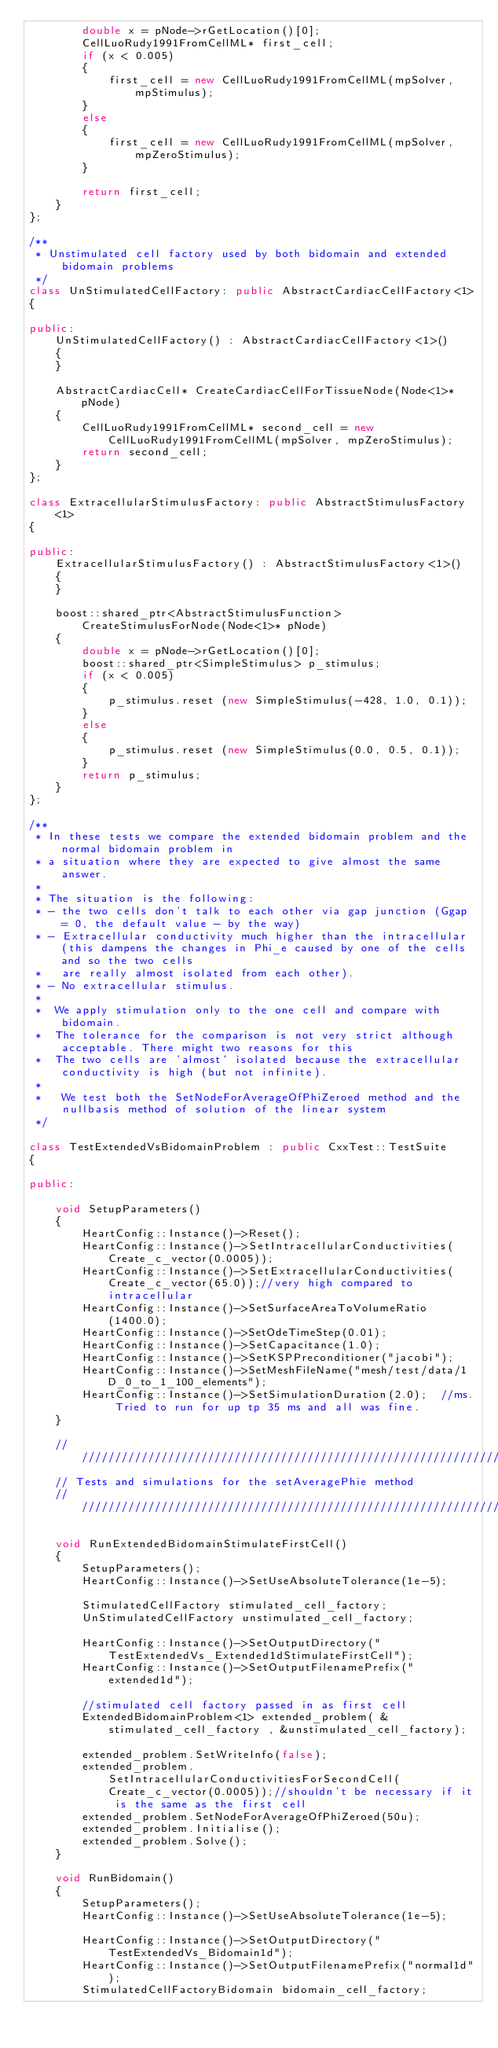Convert code to text. <code><loc_0><loc_0><loc_500><loc_500><_C++_>        double x = pNode->rGetLocation()[0];
        CellLuoRudy1991FromCellML* first_cell;
        if (x < 0.005)
        {
            first_cell = new CellLuoRudy1991FromCellML(mpSolver, mpStimulus);
        }
        else
        {
            first_cell = new CellLuoRudy1991FromCellML(mpSolver, mpZeroStimulus);
        }

        return first_cell;
    }
};

/**
 * Unstimulated cell factory used by both bidomain and extended bidomain problems
 */
class UnStimulatedCellFactory: public AbstractCardiacCellFactory<1>
{

public:
    UnStimulatedCellFactory() : AbstractCardiacCellFactory<1>()
    {
    }

    AbstractCardiacCell* CreateCardiacCellForTissueNode(Node<1>* pNode)
    {
        CellLuoRudy1991FromCellML* second_cell = new CellLuoRudy1991FromCellML(mpSolver, mpZeroStimulus);
        return second_cell;
    }
};

class ExtracellularStimulusFactory: public AbstractStimulusFactory<1>
{

public:
    ExtracellularStimulusFactory() : AbstractStimulusFactory<1>()
    {
    }

    boost::shared_ptr<AbstractStimulusFunction> CreateStimulusForNode(Node<1>* pNode)
    {
        double x = pNode->rGetLocation()[0];
        boost::shared_ptr<SimpleStimulus> p_stimulus;
        if (x < 0.005)
        {
            p_stimulus.reset (new SimpleStimulus(-428, 1.0, 0.1));
        }
        else
        {
            p_stimulus.reset (new SimpleStimulus(0.0, 0.5, 0.1));
        }
        return p_stimulus;
    }
};

/**
 * In these tests we compare the extended bidomain problem and the normal bidomain problem in
 * a situation where they are expected to give almost the same answer.
 *
 * The situation is the following:
 * - the two cells don't talk to each other via gap junction (Ggap = 0, the default value - by the way)
 * - Extracellular conductivity much higher than the intracellular (this dampens the changes in Phi_e caused by one of the cells and so the two cells
 *   are really almost isolated from each other).
 * - No extracellular stimulus.
 *
 *  We apply stimulation only to the one cell and compare with bidomain.
 *  The tolerance for the comparison is not very strict although acceptable. There might two reasons for this
 *  The two cells are 'almost' isolated because the extracellular conductivity is high (but not infinite).
 *
 *   We test both the SetNodeForAverageOfPhiZeroed method and the nullbasis method of solution of the linear system
 */

class TestExtendedVsBidomainProblem : public CxxTest::TestSuite
{

public:

    void SetupParameters()
    {
        HeartConfig::Instance()->Reset();
        HeartConfig::Instance()->SetIntracellularConductivities(Create_c_vector(0.0005));
        HeartConfig::Instance()->SetExtracellularConductivities(Create_c_vector(65.0));//very high compared to intracellular
        HeartConfig::Instance()->SetSurfaceAreaToVolumeRatio(1400.0);
        HeartConfig::Instance()->SetOdeTimeStep(0.01);
        HeartConfig::Instance()->SetCapacitance(1.0);
        HeartConfig::Instance()->SetKSPPreconditioner("jacobi");
        HeartConfig::Instance()->SetMeshFileName("mesh/test/data/1D_0_to_1_100_elements");
        HeartConfig::Instance()->SetSimulationDuration(2.0);  //ms. Tried to run for up tp 35 ms and all was fine.
    }

    //////////////////////////////////////////////////////////////////////////////
    // Tests and simulations for the setAveragePhie method
    //////////////////////////////////////////////////////////////////////////////

    void RunExtendedBidomainStimulateFirstCell()
    {
        SetupParameters();
        HeartConfig::Instance()->SetUseAbsoluteTolerance(1e-5);

        StimulatedCellFactory stimulated_cell_factory;
        UnStimulatedCellFactory unstimulated_cell_factory;

        HeartConfig::Instance()->SetOutputDirectory("TestExtendedVs_Extended1dStimulateFirstCell");
        HeartConfig::Instance()->SetOutputFilenamePrefix("extended1d");

        //stimulated cell factory passed in as first cell
        ExtendedBidomainProblem<1> extended_problem( &stimulated_cell_factory , &unstimulated_cell_factory);

        extended_problem.SetWriteInfo(false);
        extended_problem.SetIntracellularConductivitiesForSecondCell(Create_c_vector(0.0005));//shouldn't be necessary if it is the same as the first cell
        extended_problem.SetNodeForAverageOfPhiZeroed(50u);
        extended_problem.Initialise();
        extended_problem.Solve();
    }

    void RunBidomain()
    {
        SetupParameters();
        HeartConfig::Instance()->SetUseAbsoluteTolerance(1e-5);

        HeartConfig::Instance()->SetOutputDirectory("TestExtendedVs_Bidomain1d");
        HeartConfig::Instance()->SetOutputFilenamePrefix("normal1d");
        StimulatedCellFactoryBidomain bidomain_cell_factory;</code> 